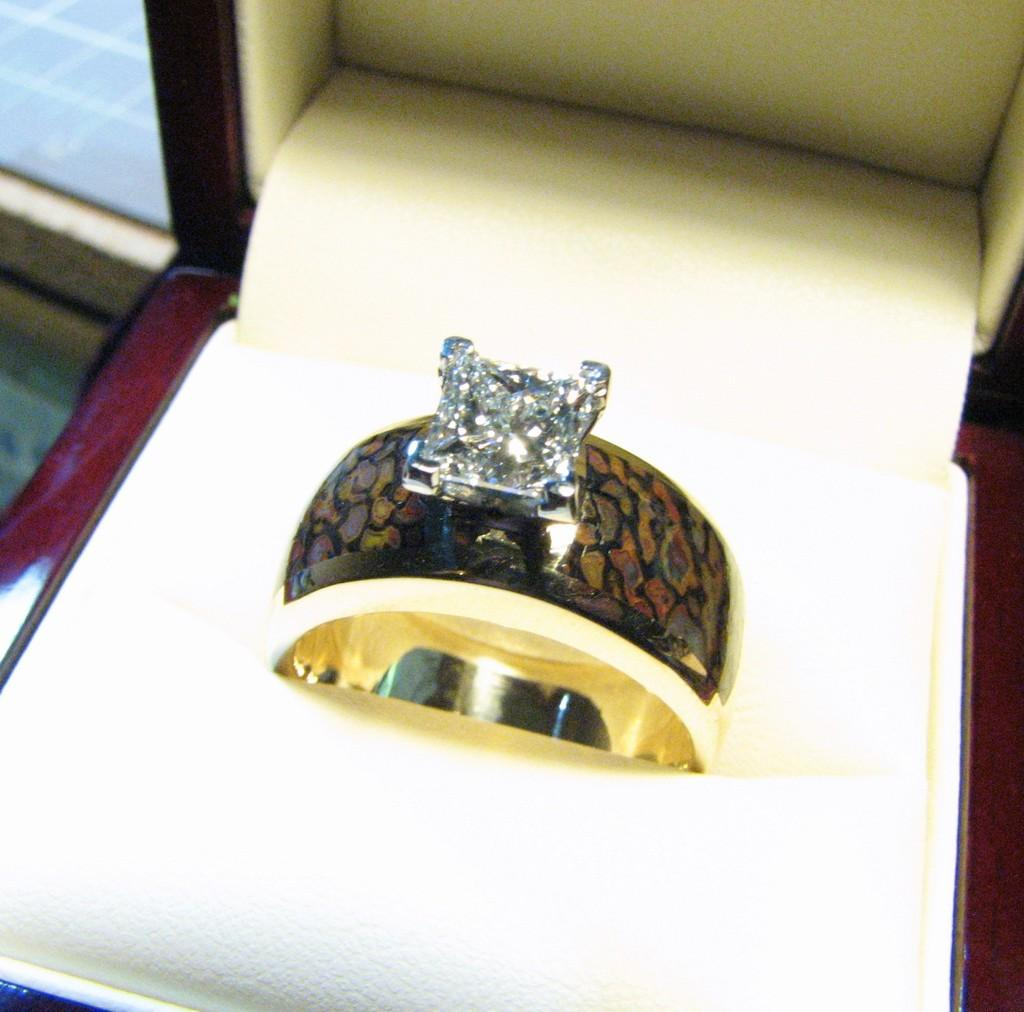What is the main object in the image? There is a ring in the image. What type of stone is featured on the ring? The ring appears to have a diamond stone. What other object is present in the image? There is a box in the image. Can you tell me how the plant is tempering the trail in the image? There is no plant or trail present in the image; it only features a ring and a box. 